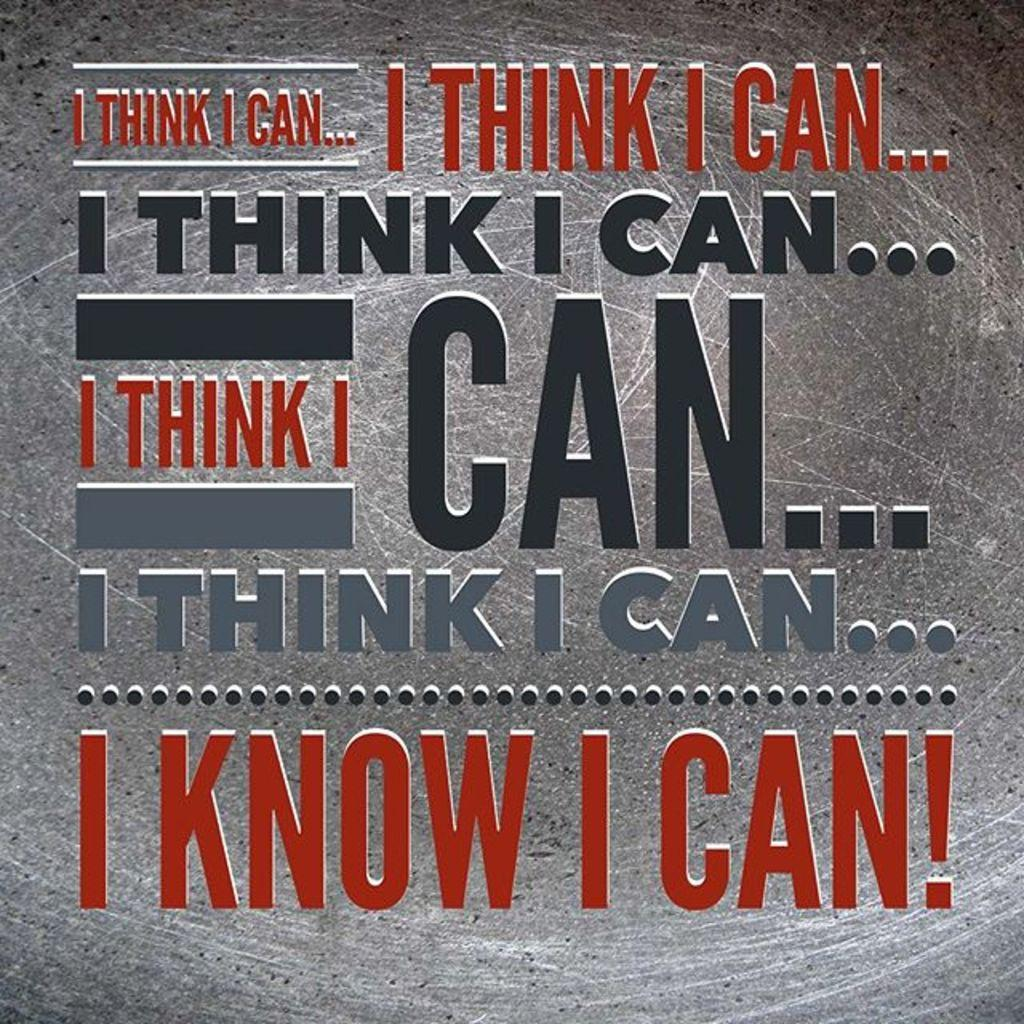<image>
Render a clear and concise summary of the photo. A motivational poster repeats the phrase I Think I Can, in different sizes and colors. 